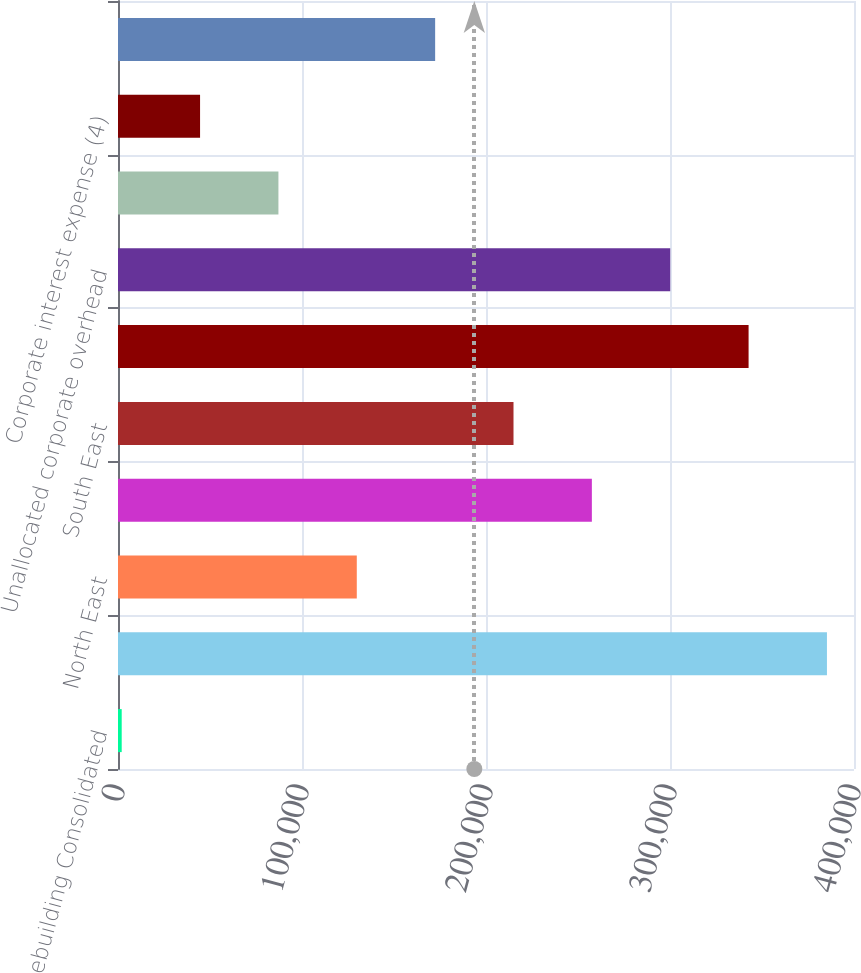<chart> <loc_0><loc_0><loc_500><loc_500><bar_chart><fcel>Homebuilding Consolidated<fcel>Mid Atlantic<fcel>North East<fcel>Mid East<fcel>South East<fcel>Corporate capital allocation<fcel>Unallocated corporate overhead<fcel>Consolidation adjustments and<fcel>Corporate interest expense (4)<fcel>Reconciling items sub-total<nl><fcel>2014<fcel>385297<fcel>129775<fcel>257536<fcel>214949<fcel>342710<fcel>300123<fcel>87188<fcel>44601<fcel>172362<nl></chart> 